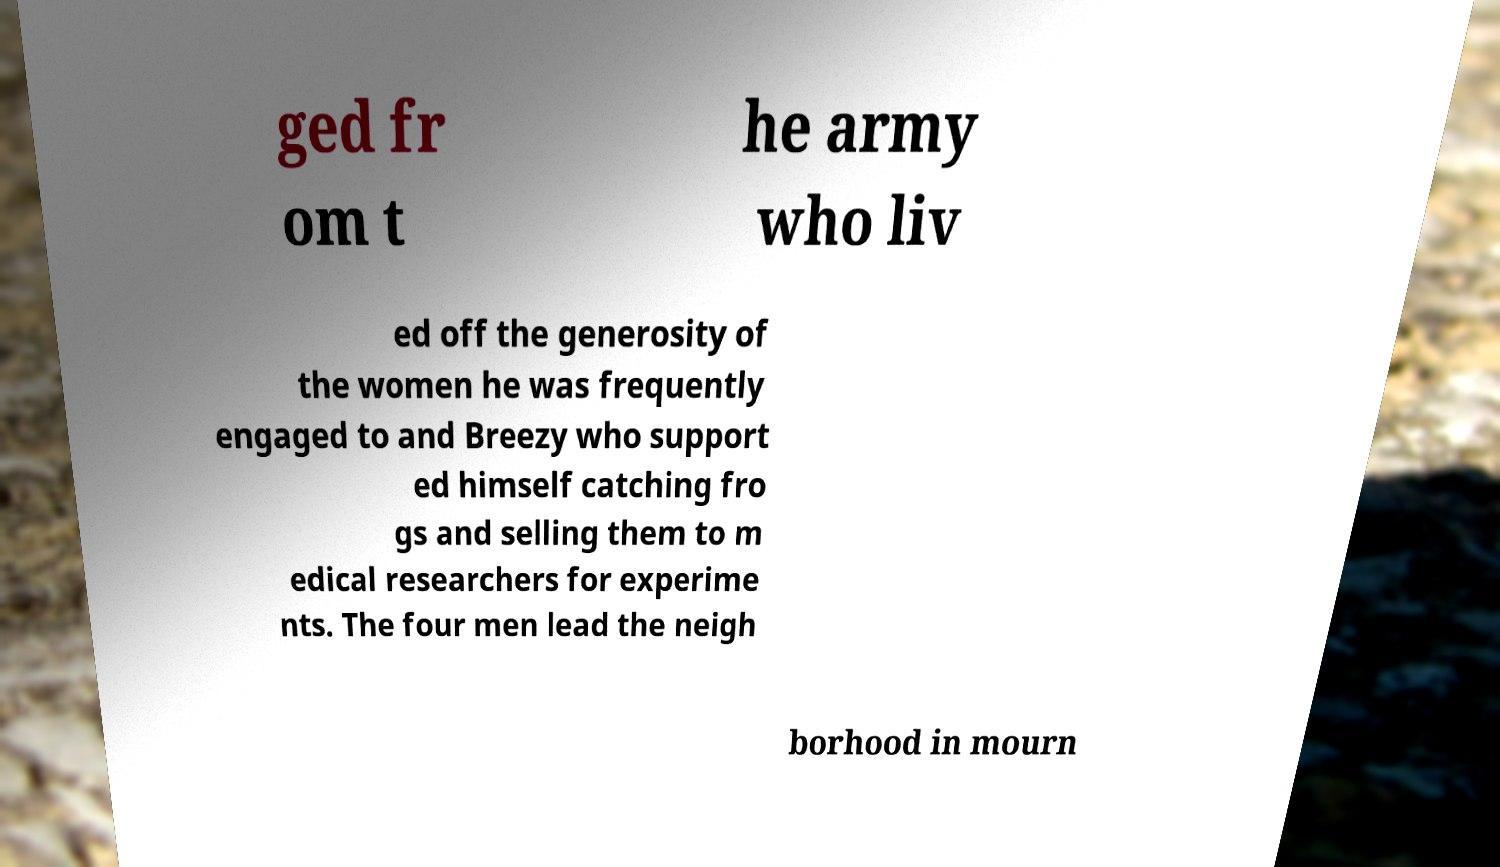Can you accurately transcribe the text from the provided image for me? ged fr om t he army who liv ed off the generosity of the women he was frequently engaged to and Breezy who support ed himself catching fro gs and selling them to m edical researchers for experime nts. The four men lead the neigh borhood in mourn 